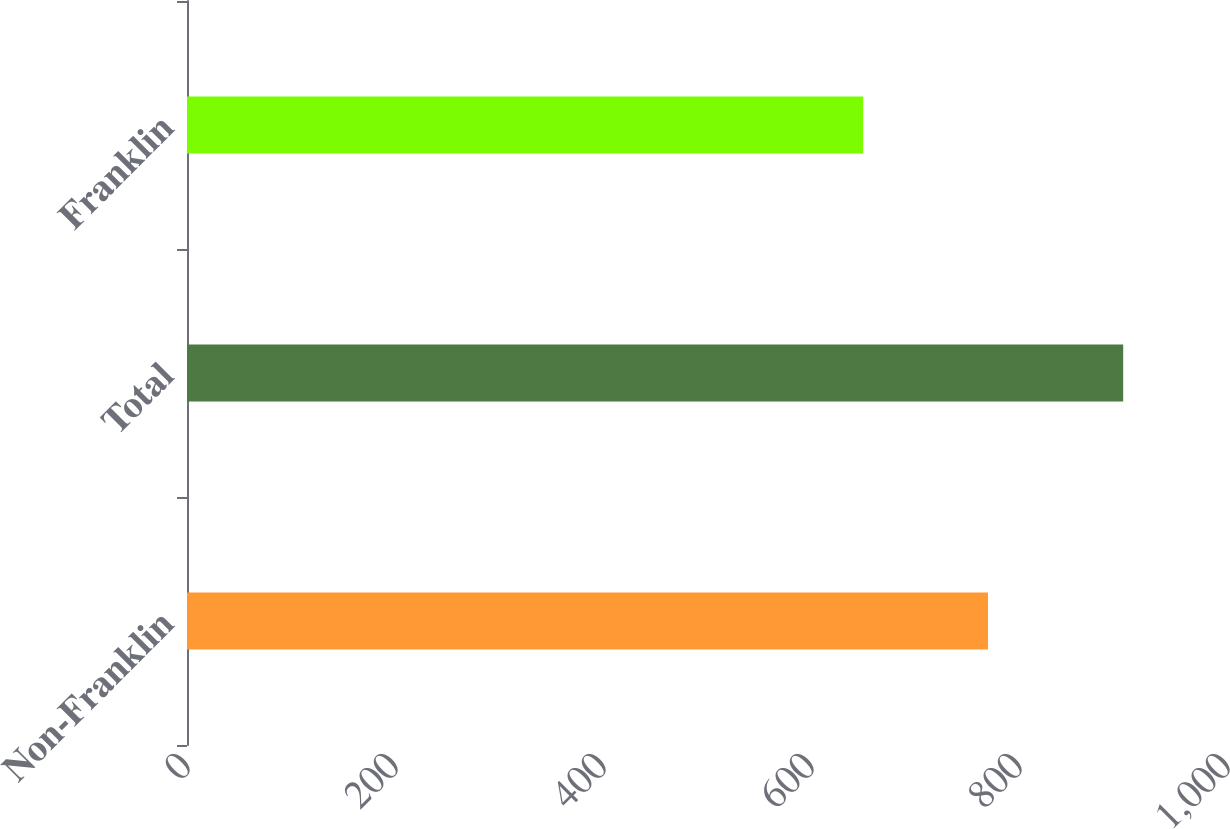<chart> <loc_0><loc_0><loc_500><loc_500><bar_chart><fcel>Non-Franklin<fcel>Total<fcel>Franklin<nl><fcel>770.2<fcel>900.2<fcel>650.2<nl></chart> 